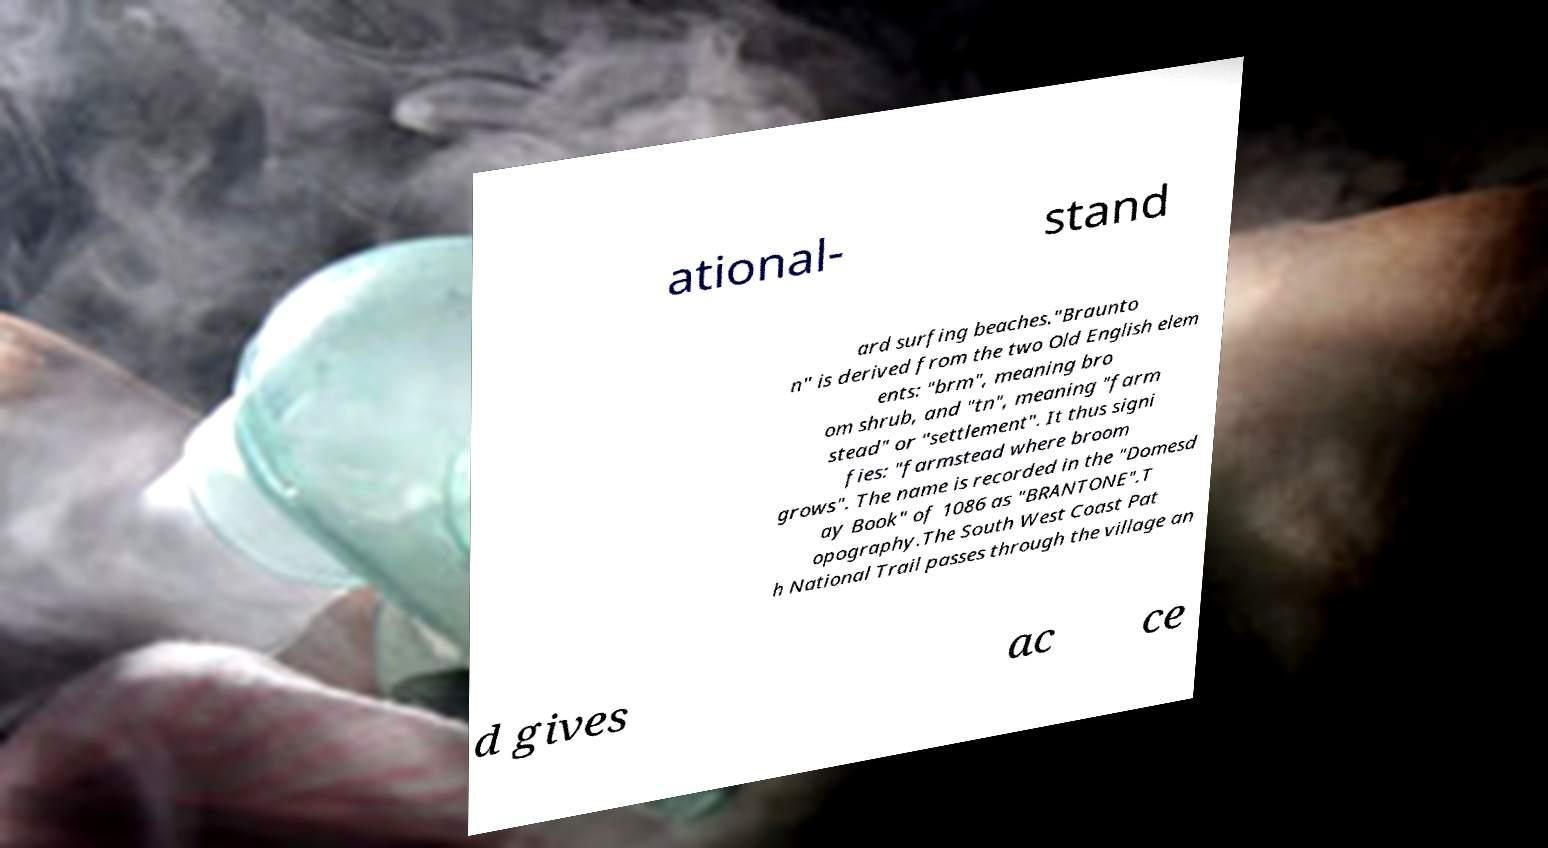Please read and relay the text visible in this image. What does it say? ational- stand ard surfing beaches."Braunto n" is derived from the two Old English elem ents: "brm", meaning bro om shrub, and "tn", meaning "farm stead" or "settlement". It thus signi fies: "farmstead where broom grows". The name is recorded in the "Domesd ay Book" of 1086 as "BRANTONE".T opography.The South West Coast Pat h National Trail passes through the village an d gives ac ce 